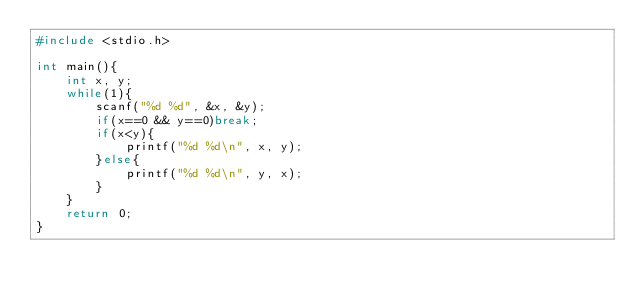Convert code to text. <code><loc_0><loc_0><loc_500><loc_500><_C_>#include <stdio.h>

int main(){
    int x, y;
    while(1){
        scanf("%d %d", &x, &y);
        if(x==0 && y==0)break;
        if(x<y){
            printf("%d %d\n", x, y);
        }else{
            printf("%d %d\n", y, x);
        }
    }
    return 0;
}</code> 